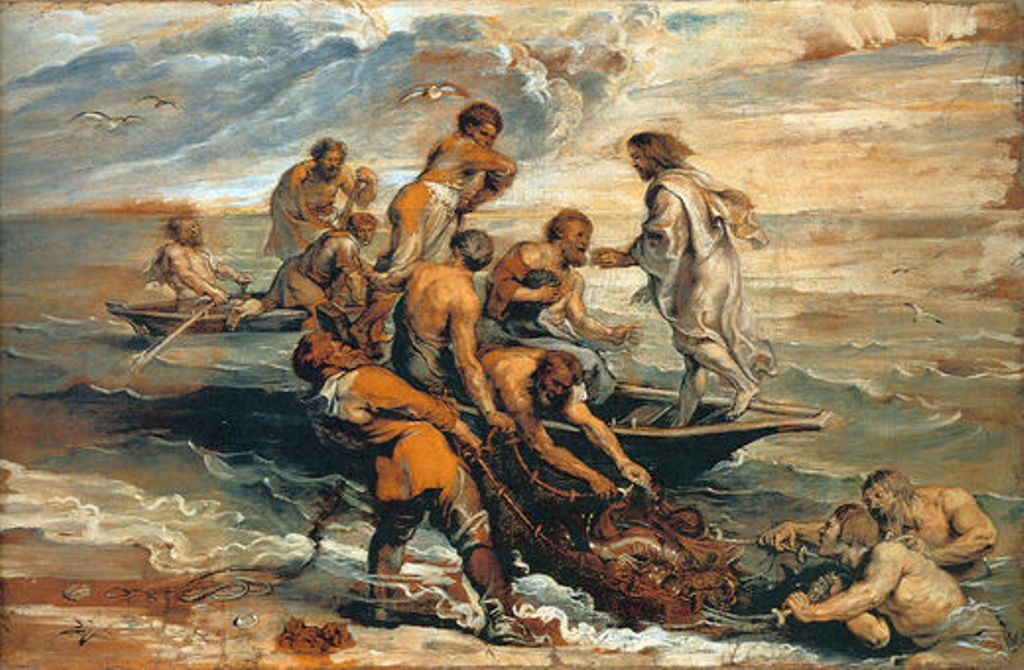What is this photo about? The image depicts an oil painting in the Baroque style, characterized by its dynamic movement and dramatic contrast in lighting. This particular painting portrays a legendary or mythological scene set in a tumultuous ocean landscape. Figures struggle with a sea creature, likely representing a myth possibly of sea gods or heroes. Each character is rendered with dramatic gestures and expressions, which is typical in Baroque art to evoke emotional engagement from the viewer. The use of earthy and subdued tones interrupted by the vivid blues of the sea and the sky not only catches the eye but also highlights the central action, adding a deeper narrative layer to the painting. 